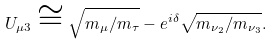<formula> <loc_0><loc_0><loc_500><loc_500>U _ { \mu 3 } \cong \sqrt { m _ { \mu } / m _ { \tau } } - e ^ { i \delta } \sqrt { m _ { \nu _ { 2 } } / m _ { \nu _ { 3 } } } .</formula> 